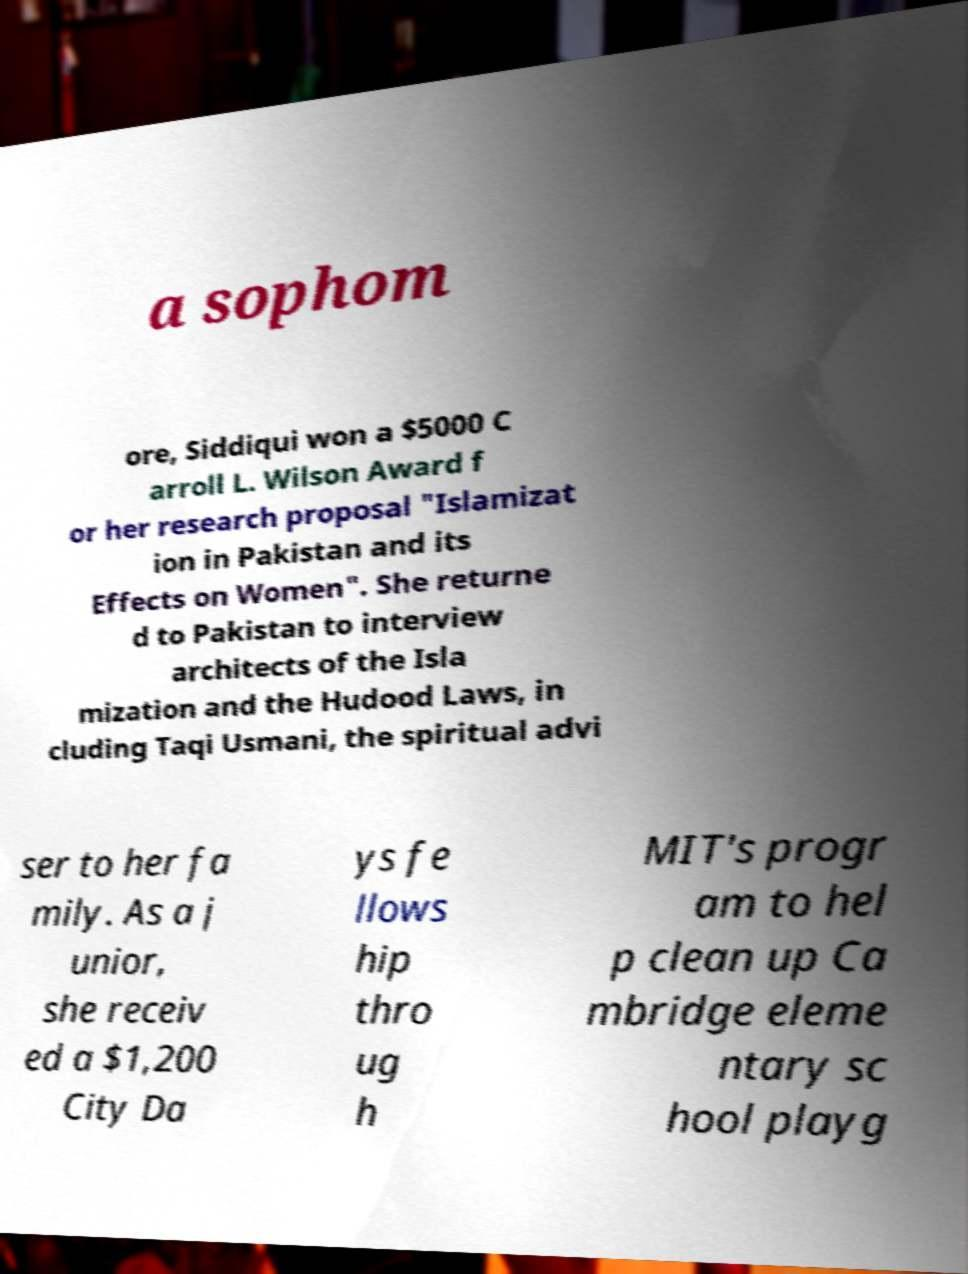Please identify and transcribe the text found in this image. a sophom ore, Siddiqui won a $5000 C arroll L. Wilson Award f or her research proposal "Islamizat ion in Pakistan and its Effects on Women". She returne d to Pakistan to interview architects of the Isla mization and the Hudood Laws, in cluding Taqi Usmani, the spiritual advi ser to her fa mily. As a j unior, she receiv ed a $1,200 City Da ys fe llows hip thro ug h MIT's progr am to hel p clean up Ca mbridge eleme ntary sc hool playg 